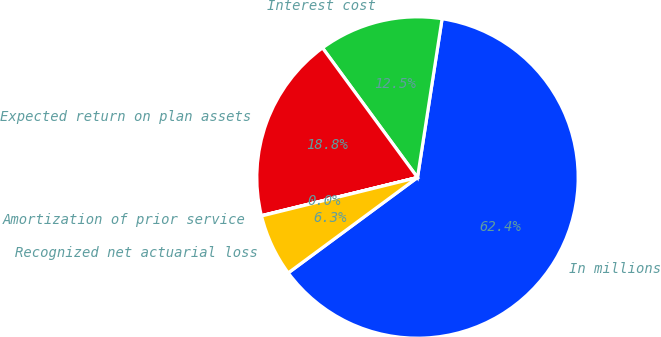<chart> <loc_0><loc_0><loc_500><loc_500><pie_chart><fcel>In millions<fcel>Interest cost<fcel>Expected return on plan assets<fcel>Amortization of prior service<fcel>Recognized net actuarial loss<nl><fcel>62.43%<fcel>12.51%<fcel>18.75%<fcel>0.03%<fcel>6.27%<nl></chart> 